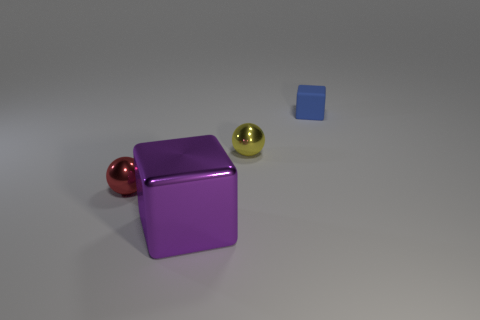Is there anything else that is the same material as the tiny cube?
Your answer should be very brief. No. Is there anything else that is the same size as the purple metal cube?
Offer a terse response. No. What number of objects are tiny red metallic balls that are left of the yellow thing or blocks behind the yellow metallic ball?
Provide a short and direct response. 2. What material is the yellow thing that is the same shape as the red object?
Keep it short and to the point. Metal. Is there a small red metallic thing?
Provide a short and direct response. Yes. There is a metallic thing that is behind the big purple thing and right of the red metal ball; what is its size?
Keep it short and to the point. Small. What is the shape of the purple object?
Make the answer very short. Cube. Are there any red spheres left of the tiny ball behind the small red sphere?
Ensure brevity in your answer.  Yes. What material is the block that is the same size as the red object?
Provide a succinct answer. Rubber. Is there another red object of the same size as the matte object?
Keep it short and to the point. Yes. 